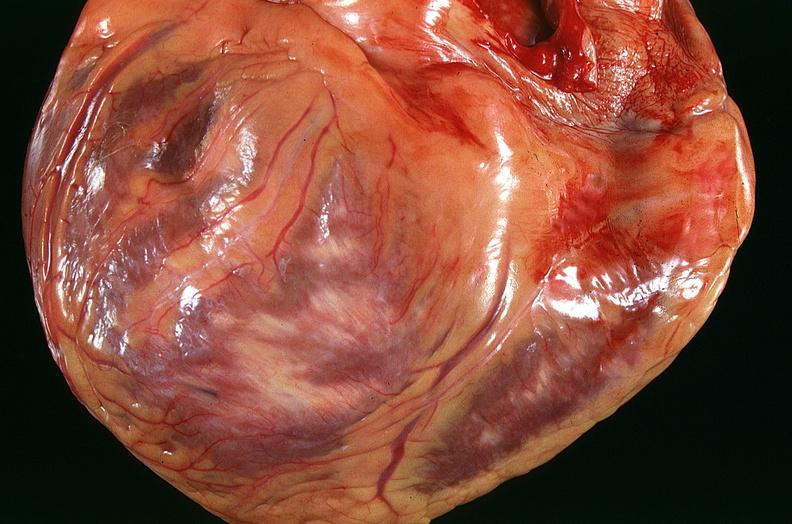does nodular tumor show congestive heart failure, three vessel coronary artery disease?
Answer the question using a single word or phrase. No 